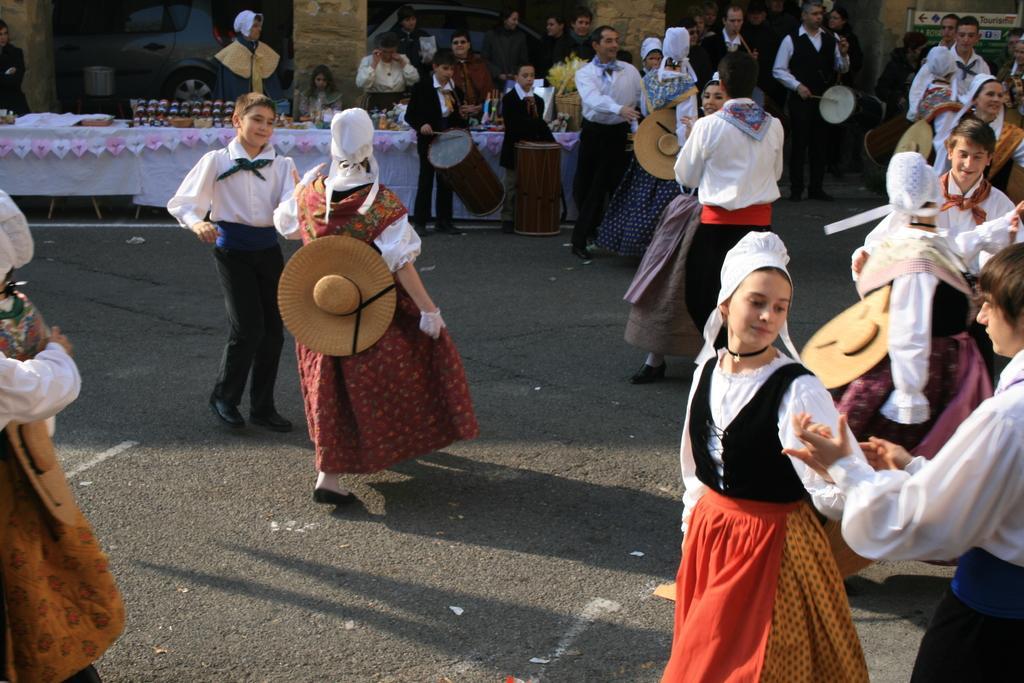How would you summarize this image in a sentence or two? In this picture we can see some persons are dancing on the road. Even we can see few people are playing drums. And this is the table and there is a white colored cloth on the table. And there is a wall in the background. 